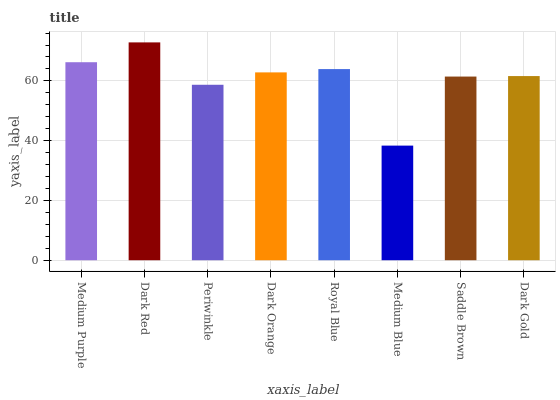Is Medium Blue the minimum?
Answer yes or no. Yes. Is Dark Red the maximum?
Answer yes or no. Yes. Is Periwinkle the minimum?
Answer yes or no. No. Is Periwinkle the maximum?
Answer yes or no. No. Is Dark Red greater than Periwinkle?
Answer yes or no. Yes. Is Periwinkle less than Dark Red?
Answer yes or no. Yes. Is Periwinkle greater than Dark Red?
Answer yes or no. No. Is Dark Red less than Periwinkle?
Answer yes or no. No. Is Dark Orange the high median?
Answer yes or no. Yes. Is Dark Gold the low median?
Answer yes or no. Yes. Is Periwinkle the high median?
Answer yes or no. No. Is Periwinkle the low median?
Answer yes or no. No. 